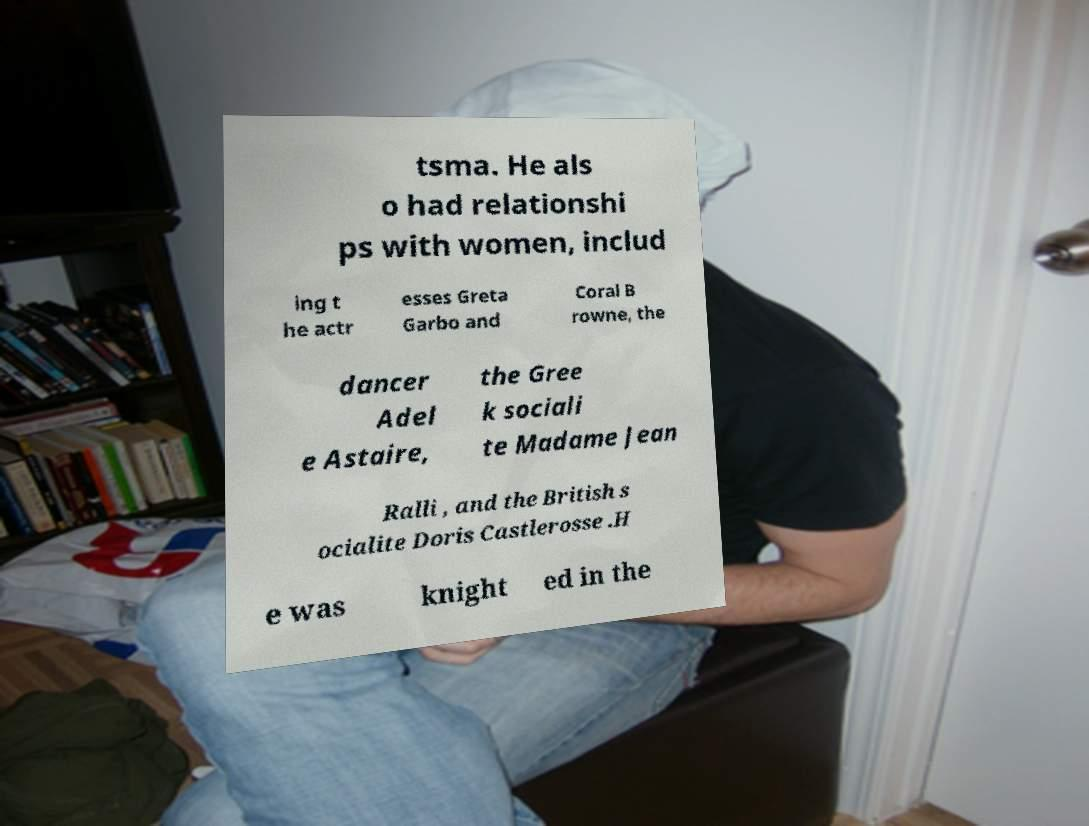For documentation purposes, I need the text within this image transcribed. Could you provide that? tsma. He als o had relationshi ps with women, includ ing t he actr esses Greta Garbo and Coral B rowne, the dancer Adel e Astaire, the Gree k sociali te Madame Jean Ralli , and the British s ocialite Doris Castlerosse .H e was knight ed in the 